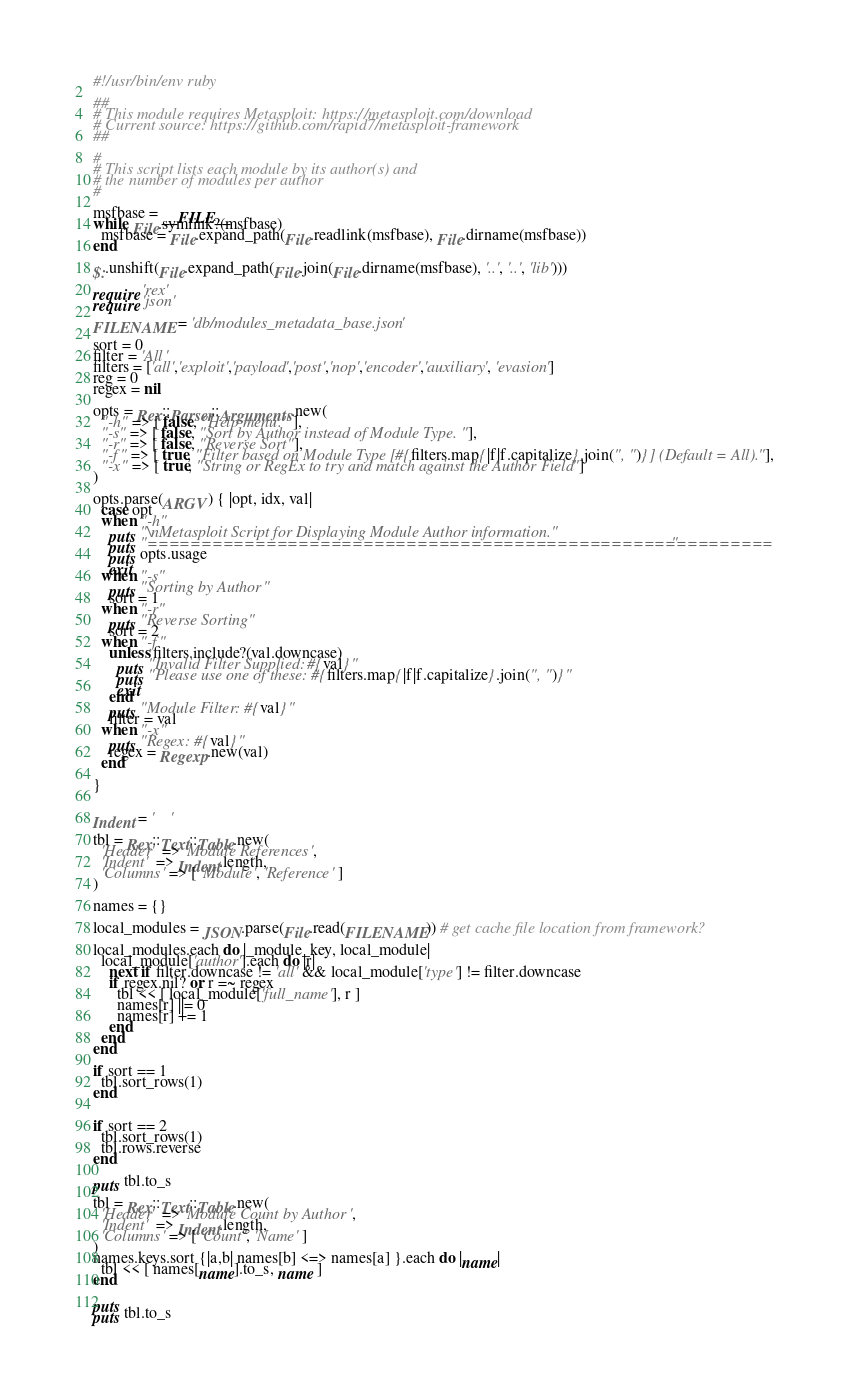Convert code to text. <code><loc_0><loc_0><loc_500><loc_500><_Ruby_>#!/usr/bin/env ruby

##
# This module requires Metasploit: https://metasploit.com/download
# Current source: https://github.com/rapid7/metasploit-framework
##

#
# This script lists each module by its author(s) and
# the number of modules per author
#

msfbase = __FILE__
while File.symlink?(msfbase)
  msfbase = File.expand_path(File.readlink(msfbase), File.dirname(msfbase))
end

$:.unshift(File.expand_path(File.join(File.dirname(msfbase), '..', '..', 'lib')))

require 'rex'
require 'json'

FILENAME = 'db/modules_metadata_base.json'

sort = 0
filter = 'All'
filters = ['all','exploit','payload','post','nop','encoder','auxiliary', 'evasion']
reg = 0
regex = nil

opts = Rex::Parser::Arguments.new(
  "-h" => [ false, "Help menu." ],
  "-s" => [ false, "Sort by Author instead of Module Type."],
  "-r" => [ false, "Reverse Sort"],
  "-f" => [ true, "Filter based on Module Type [#{filters.map{|f|f.capitalize}.join(", ")}] (Default = All)."],
  "-x" => [ true, "String or RegEx to try and match against the Author Field"]
)

opts.parse(ARGV) { |opt, idx, val|
  case opt
  when "-h"
    puts "\nMetasploit Script for Displaying Module Author information."
    puts "=========================================================="
    puts opts.usage
    exit
  when "-s"
    puts "Sorting by Author"
    sort = 1
  when "-r"
    puts "Reverse Sorting"
    sort = 2
  when "-f"
    unless filters.include?(val.downcase)
      puts "Invalid Filter Supplied: #{val}"
      puts "Please use one of these: #{filters.map{|f|f.capitalize}.join(", ")}"
      exit
    end
    puts "Module Filter: #{val}"
    filter = val
  when "-x"
    puts "Regex: #{val}"
    regex = Regexp.new(val)
  end

}


Indent = '    '

tbl = Rex::Text::Table.new(
  'Header'  => 'Module References',
  'Indent'  => Indent.length,
  'Columns' => [ 'Module', 'Reference' ]
)

names = {}

local_modules = JSON.parse(File.read(FILENAME)) # get cache file location from framework?

local_modules.each do |_module_key, local_module|
  local_module['author'].each do |r|
    next if filter.downcase != 'all' && local_module['type'] != filter.downcase
    if regex.nil? or r =~ regex
      tbl << [ local_module['full_name'], r ]
      names[r] ||= 0
      names[r] += 1
    end
  end
end

if sort == 1
  tbl.sort_rows(1)
end


if sort == 2
  tbl.sort_rows(1)
  tbl.rows.reverse
end

puts tbl.to_s

tbl = Rex::Text::Table.new(
  'Header'  => 'Module Count by Author',
  'Indent'  => Indent.length,
  'Columns' => [ 'Count', 'Name' ]
)
names.keys.sort {|a,b| names[b] <=> names[a] }.each do |name|
  tbl << [ names[name].to_s, name ]
end

puts
puts tbl.to_s
</code> 